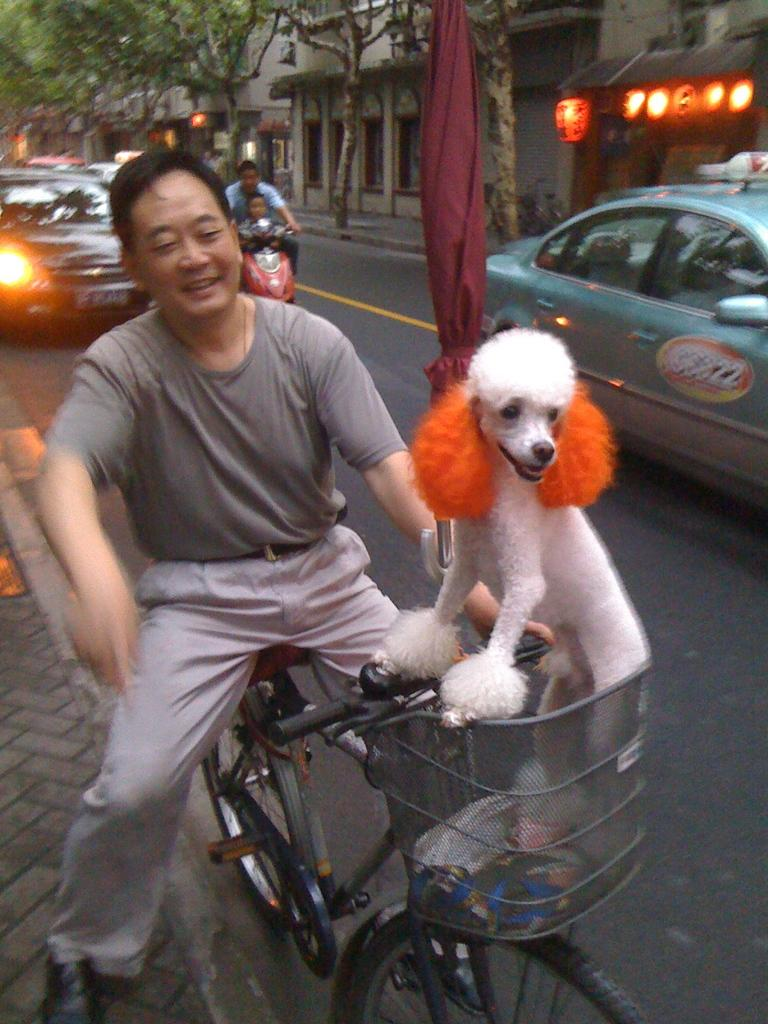What is the man doing in the image? The man is on a bicycle in the image. What is in the basket of the bicycle? There is a dog in the basket of the bicycle. What can be seen in the background of the image? There is a car, a bike, buildings, and trees in the background of the image. What word is written on the button in the image? There is no button present in the image, so it is not possible to answer that question. 